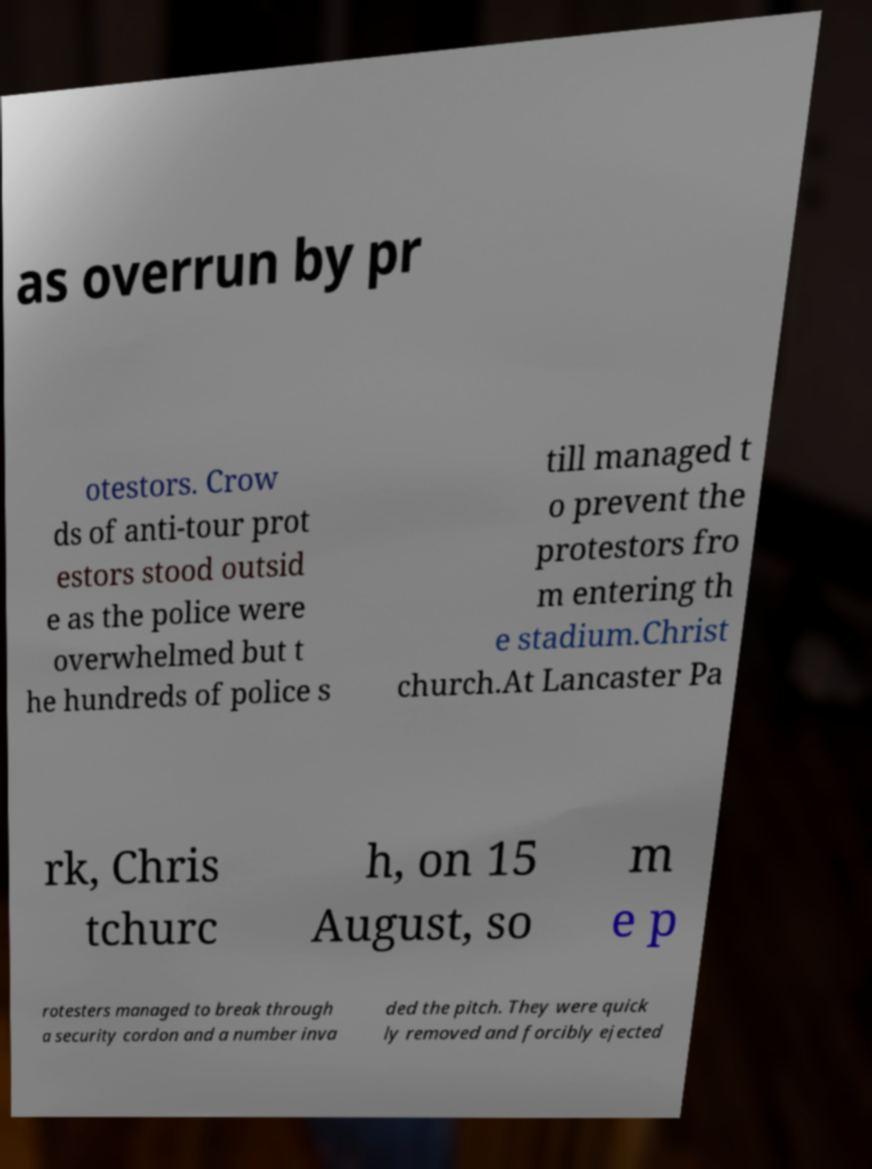Please identify and transcribe the text found in this image. as overrun by pr otestors. Crow ds of anti-tour prot estors stood outsid e as the police were overwhelmed but t he hundreds of police s till managed t o prevent the protestors fro m entering th e stadium.Christ church.At Lancaster Pa rk, Chris tchurc h, on 15 August, so m e p rotesters managed to break through a security cordon and a number inva ded the pitch. They were quick ly removed and forcibly ejected 